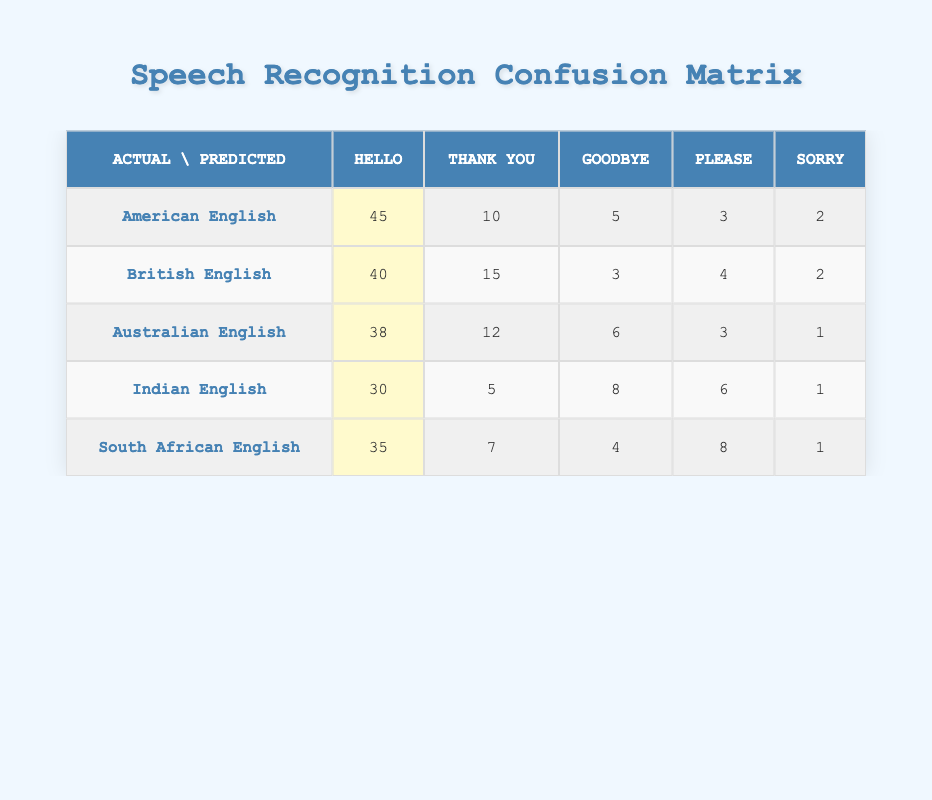What was the highest predicted count for 'thank you' among the accents? The values for 'thank you' from the table are 10 (American English), 15 (British English), 12 (Australian English), 5 (Indian English), and 7 (South African English). The highest value is 15 from British English.
Answer: 15 Which accent had the lowest recognition for the word 'sorry'? The values for 'sorry' are 2 (American English), 2 (British English), 1 (Australian English), 1 (Indian English), and 1 (South African English). The lowest count is 1, which applies to Australian, Indian, and South African English.
Answer: 1 What is the total number of predictions made for 'goodbye' across all accents? Sum the values for 'goodbye' across all accents: 5 (American) + 3 (British) + 6 (Australian) + 8 (Indian) + 4 (South African) = 26.
Answer: 26 Is it true that the recognition rate for 'hello' was highest in American English compared to other accents? The value for 'hello' in American English is 45, which is greater than other accents: 40 (British), 38 (Australian), 30 (Indian), and 35 (South African). Therefore, it is true that American English had the highest recognition for 'hello'.
Answer: Yes What is the average predicted count for 'please' across all accents? The counts for 'please' are: 3 (American) + 4 (British) + 3 (Australian) + 6 (Indian) + 8 (South African) = 24. There are 5 accents, so the average is 24/5 = 4.8.
Answer: 4.8 Which accent performed best overall in terms of correct recognition for 'hello'? The recognition counts for 'hello' from each accent are: American English (45), British English (40), Australian English (38), Indian English (30), and South African English (35). American English has the highest count of 45.
Answer: American English Calculating the total of the predicted counts for 'thank you', which accents achieved above the average count? The predicted counts for 'thank you' are 10 (American), 15 (British), 12 (Australian), 5 (Indian), and 7 (South African). The total is 49, making the average count 49/5 = 9.8. Thus, American (10), British (15), and Australian (12) are above average.
Answer: American, British, Australian Was there any accent with a count of 0 for any word? None of the accents have a count of 0 for any of the words listed ('hello', 'thank you', 'goodbye', 'please', 'sorry'). All values are above 0 across all accents.
Answer: No 